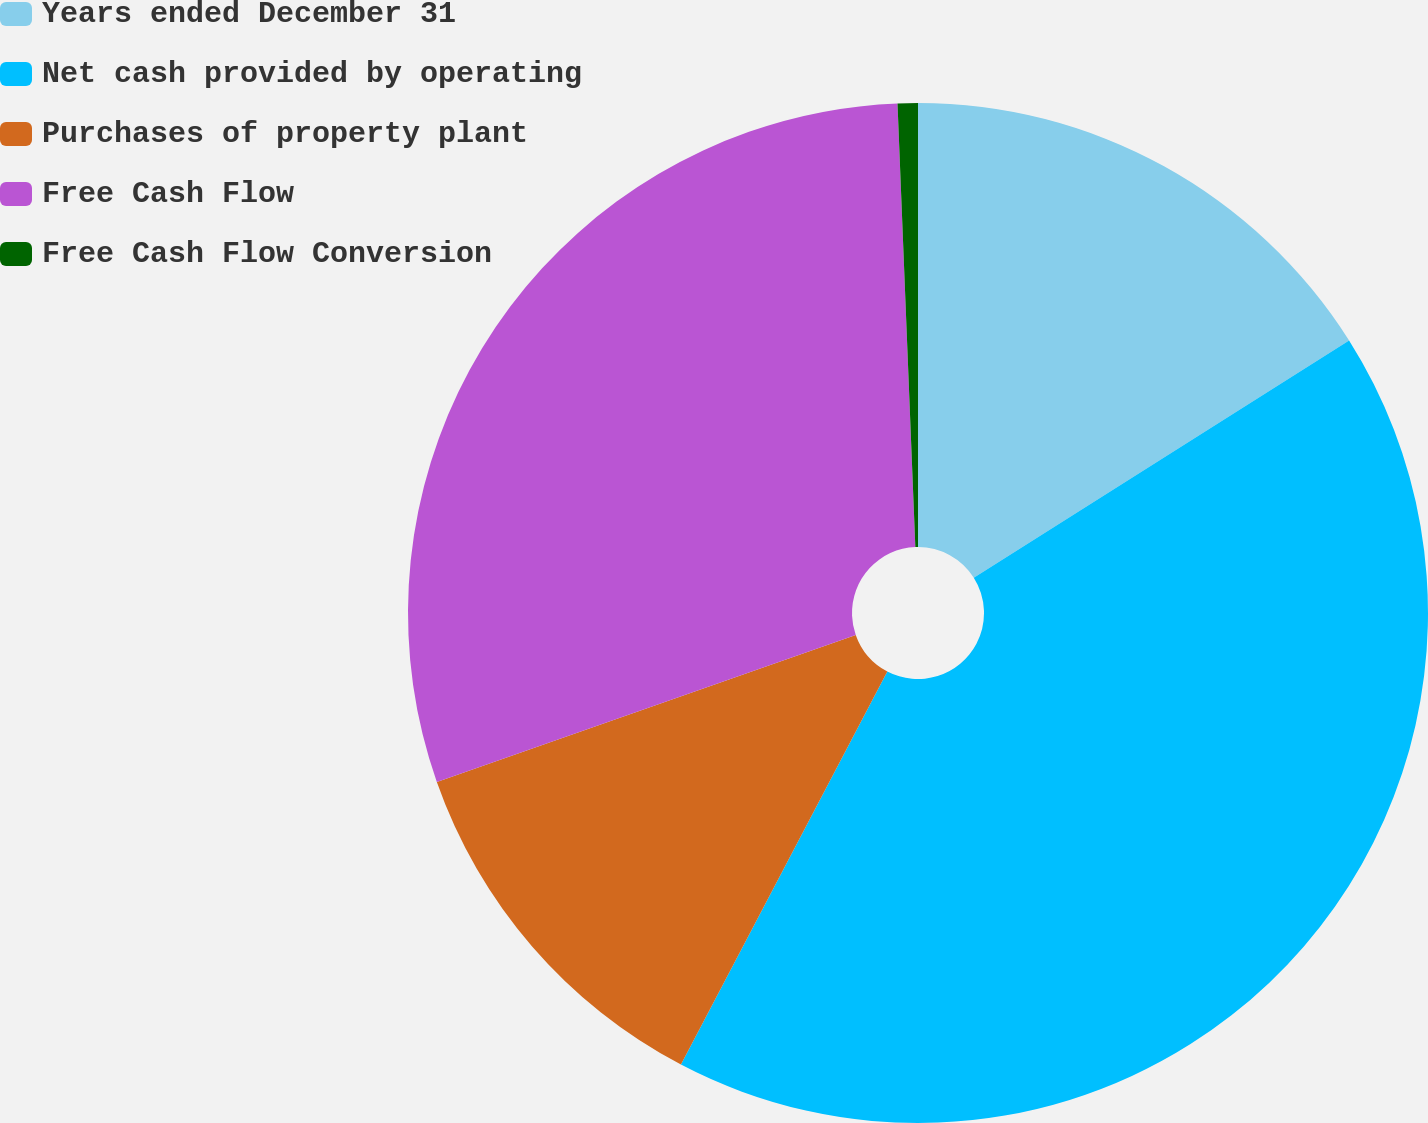<chart> <loc_0><loc_0><loc_500><loc_500><pie_chart><fcel>Years ended December 31<fcel>Net cash provided by operating<fcel>Purchases of property plant<fcel>Free Cash Flow<fcel>Free Cash Flow Conversion<nl><fcel>16.03%<fcel>41.67%<fcel>11.93%<fcel>29.74%<fcel>0.64%<nl></chart> 